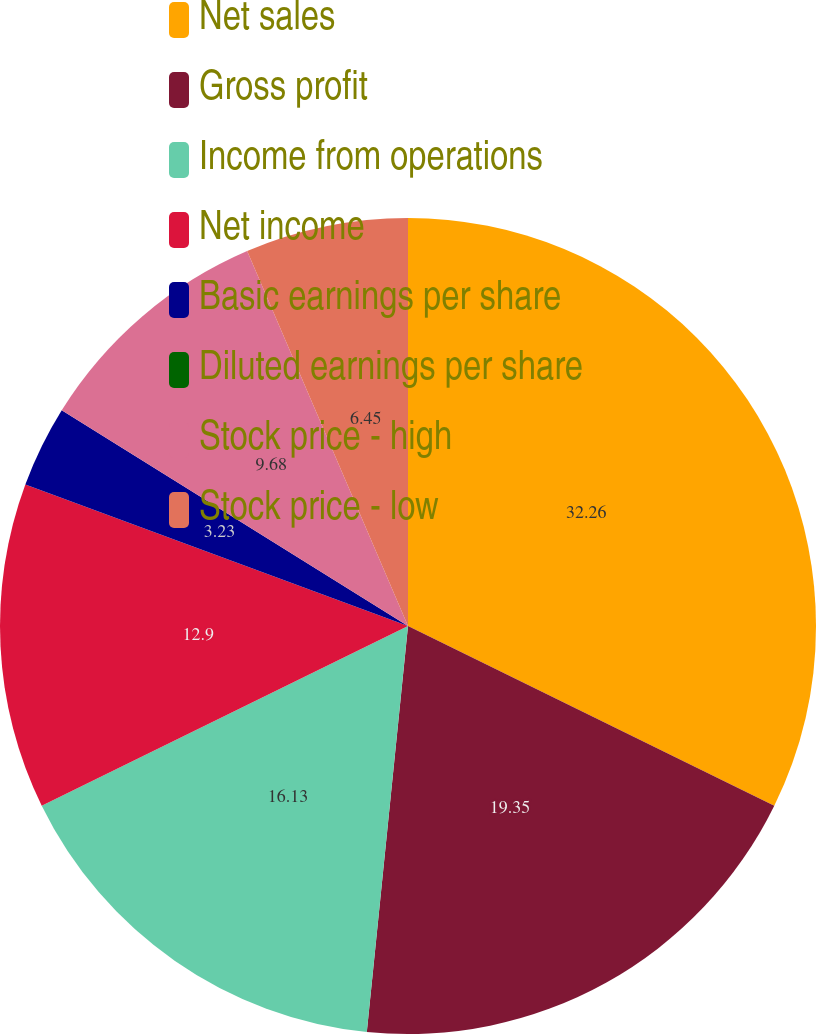Convert chart to OTSL. <chart><loc_0><loc_0><loc_500><loc_500><pie_chart><fcel>Net sales<fcel>Gross profit<fcel>Income from operations<fcel>Net income<fcel>Basic earnings per share<fcel>Diluted earnings per share<fcel>Stock price - high<fcel>Stock price - low<nl><fcel>32.26%<fcel>19.35%<fcel>16.13%<fcel>12.9%<fcel>3.23%<fcel>0.0%<fcel>9.68%<fcel>6.45%<nl></chart> 